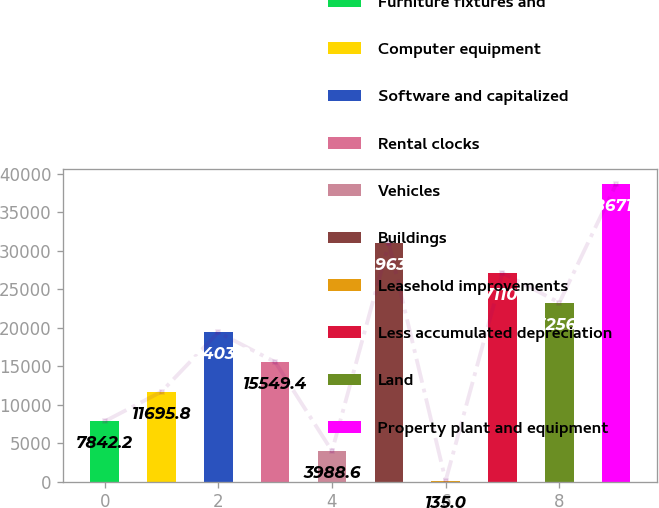Convert chart. <chart><loc_0><loc_0><loc_500><loc_500><bar_chart><fcel>Furniture fixtures and<fcel>Computer equipment<fcel>Software and capitalized<fcel>Rental clocks<fcel>Vehicles<fcel>Buildings<fcel>Leasehold improvements<fcel>Less accumulated depreciation<fcel>Land<fcel>Property plant and equipment<nl><fcel>7842.2<fcel>11695.8<fcel>19403<fcel>15549.4<fcel>3988.6<fcel>30963.8<fcel>135<fcel>27110.2<fcel>23256.6<fcel>38671<nl></chart> 